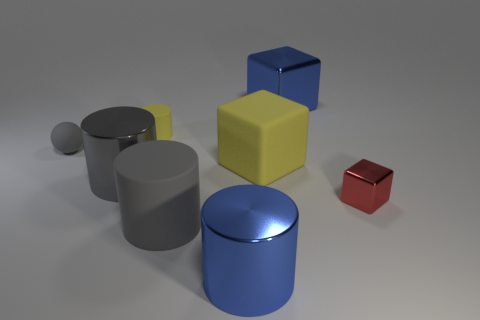Subtract all yellow matte blocks. How many blocks are left? 2 Subtract 1 blocks. How many blocks are left? 2 Add 1 tiny red balls. How many objects exist? 9 Subtract all cyan cubes. How many gray cylinders are left? 2 Subtract all gray cylinders. How many cylinders are left? 2 Subtract all large gray spheres. Subtract all gray metal objects. How many objects are left? 7 Add 6 gray rubber balls. How many gray rubber balls are left? 7 Add 7 small brown spheres. How many small brown spheres exist? 7 Subtract 0 green cylinders. How many objects are left? 8 Subtract all blocks. How many objects are left? 5 